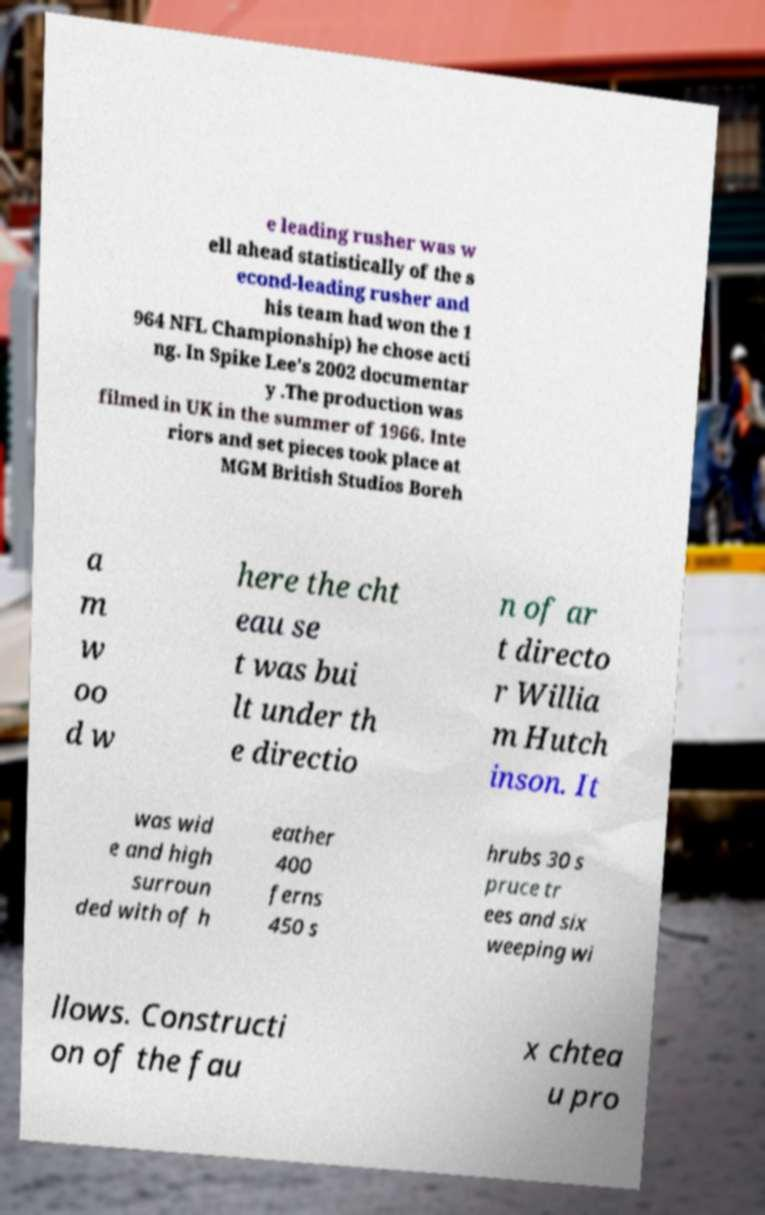I need the written content from this picture converted into text. Can you do that? e leading rusher was w ell ahead statistically of the s econd-leading rusher and his team had won the 1 964 NFL Championship) he chose acti ng. In Spike Lee's 2002 documentar y .The production was filmed in UK in the summer of 1966. Inte riors and set pieces took place at MGM British Studios Boreh a m w oo d w here the cht eau se t was bui lt under th e directio n of ar t directo r Willia m Hutch inson. It was wid e and high surroun ded with of h eather 400 ferns 450 s hrubs 30 s pruce tr ees and six weeping wi llows. Constructi on of the fau x chtea u pro 